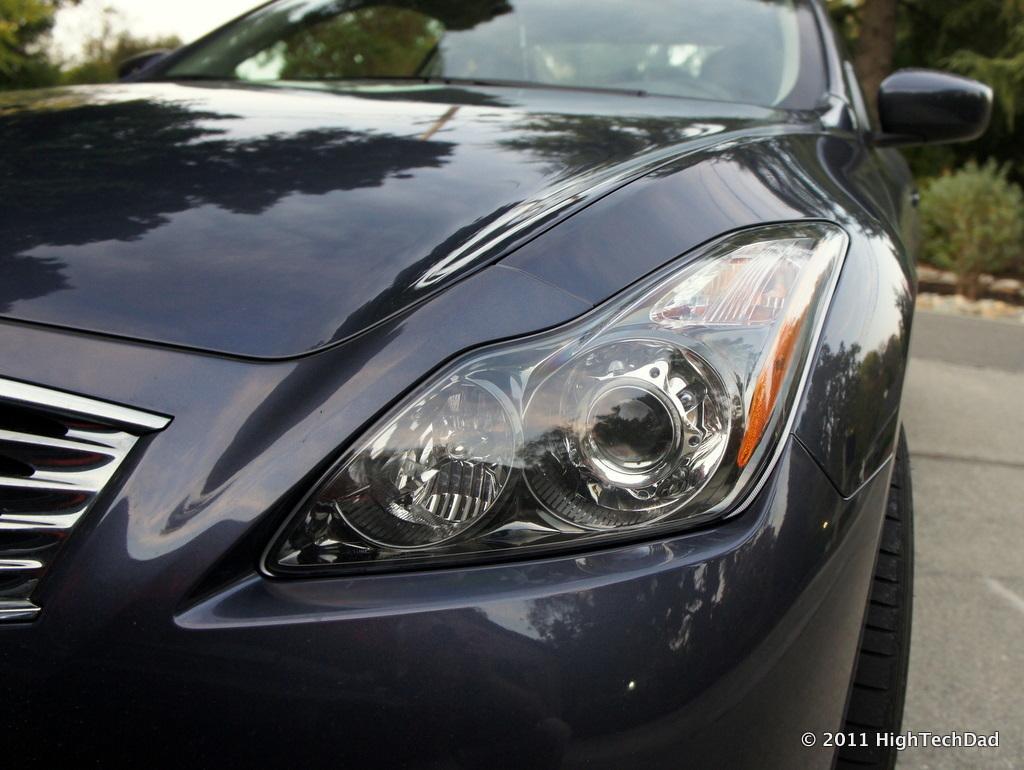Describe this image in one or two sentences. This image consists of a black car. In the background there are trees. The car is on the road. 